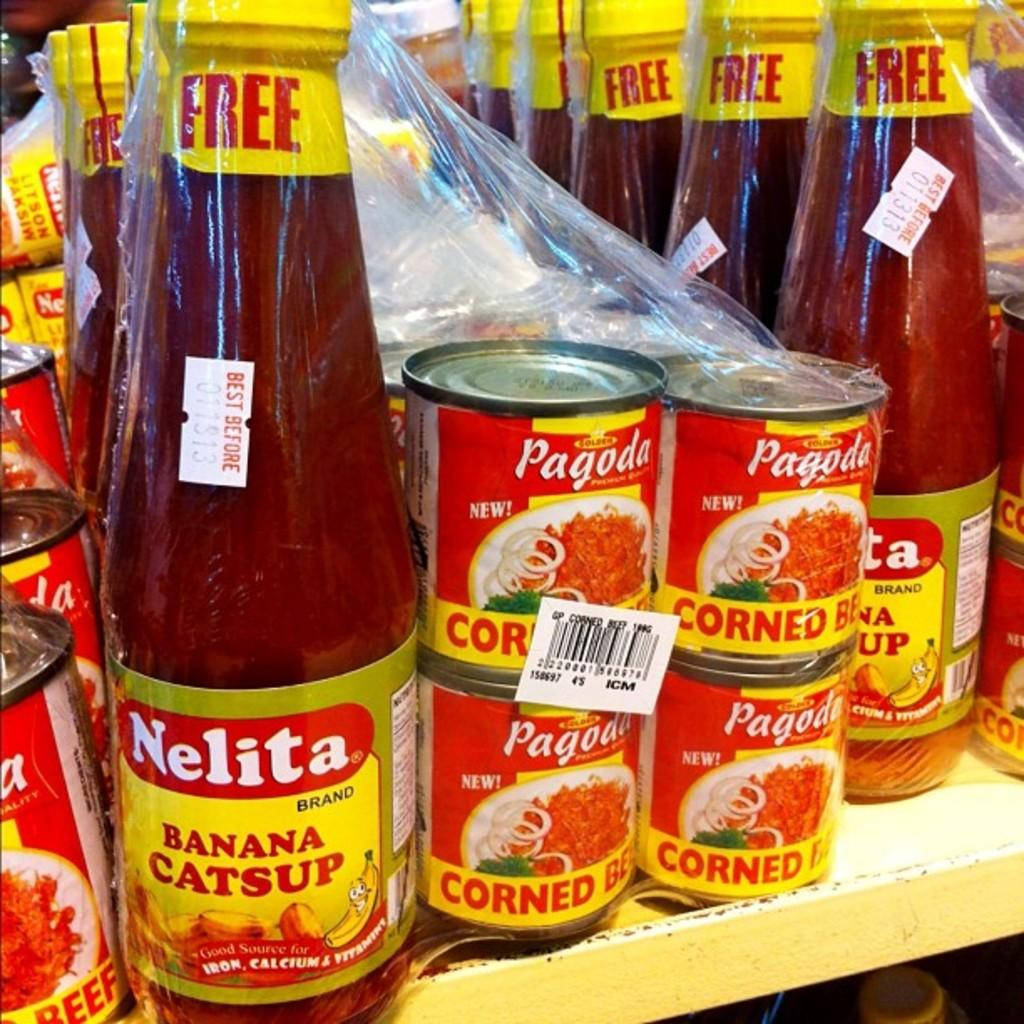<image>
Summarize the visual content of the image. A bottle of Nelita brand banana catsup is on a shelf next to corned beef. 